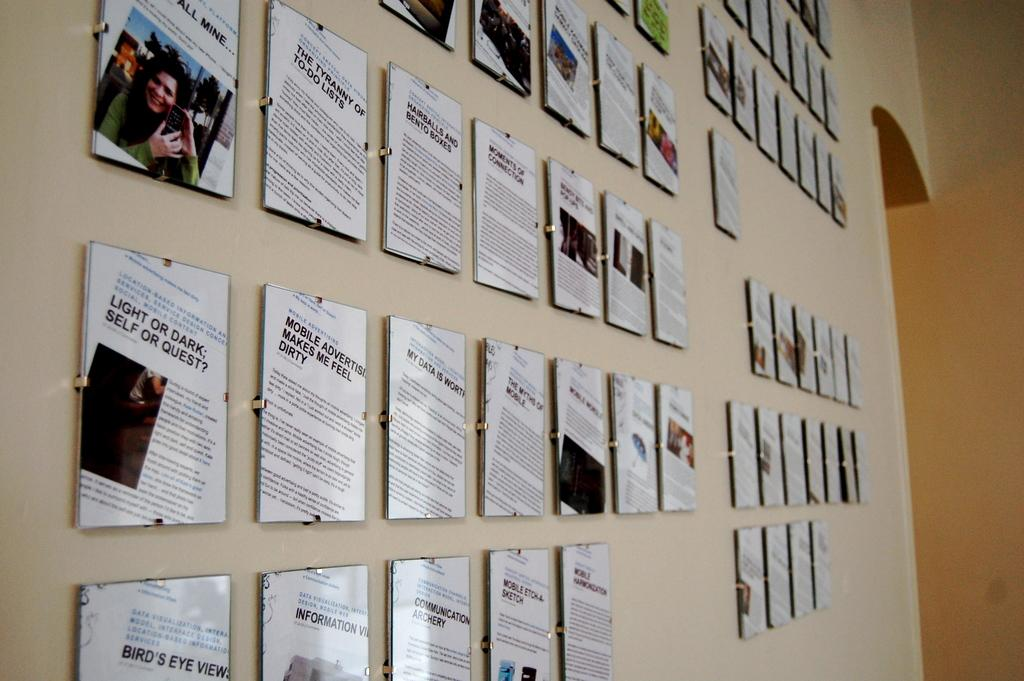<image>
Provide a brief description of the given image. A wall is lined with plaques that feature newspaper clippings and one says Light or Dark. 